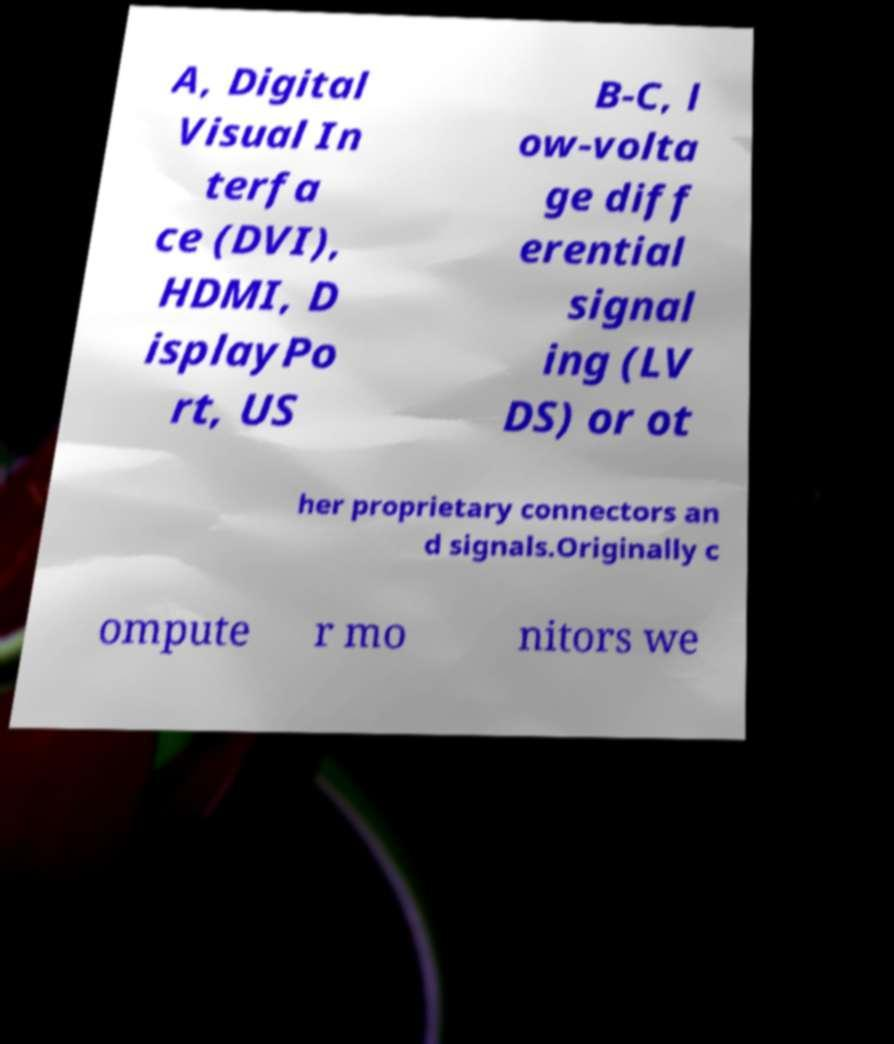There's text embedded in this image that I need extracted. Can you transcribe it verbatim? A, Digital Visual In terfa ce (DVI), HDMI, D isplayPo rt, US B-C, l ow-volta ge diff erential signal ing (LV DS) or ot her proprietary connectors an d signals.Originally c ompute r mo nitors we 